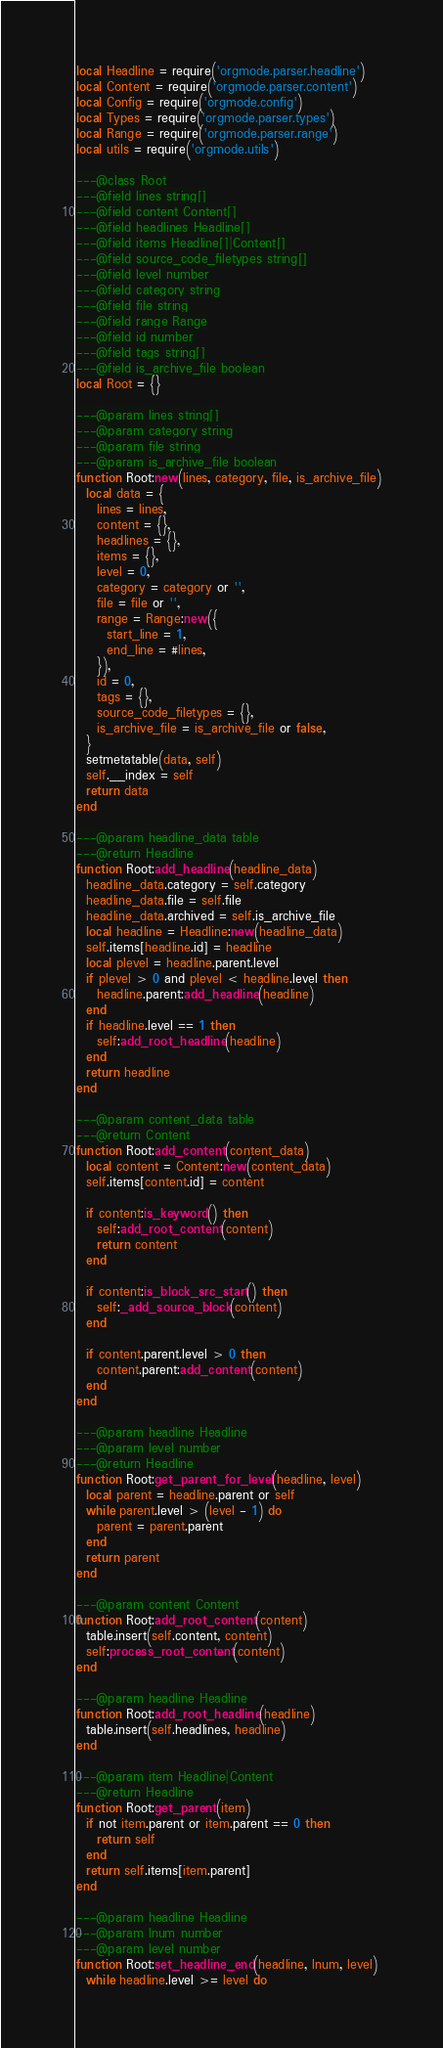Convert code to text. <code><loc_0><loc_0><loc_500><loc_500><_Lua_>local Headline = require('orgmode.parser.headline')
local Content = require('orgmode.parser.content')
local Config = require('orgmode.config')
local Types = require('orgmode.parser.types')
local Range = require('orgmode.parser.range')
local utils = require('orgmode.utils')

---@class Root
---@field lines string[]
---@field content Content[]
---@field headlines Headline[]
---@field items Headline[]|Content[]
---@field source_code_filetypes string[]
---@field level number
---@field category string
---@field file string
---@field range Range
---@field id number
---@field tags string[]
---@field is_archive_file boolean
local Root = {}

---@param lines string[]
---@param category string
---@param file string
---@param is_archive_file boolean
function Root:new(lines, category, file, is_archive_file)
  local data = {
    lines = lines,
    content = {},
    headlines = {},
    items = {},
    level = 0,
    category = category or '',
    file = file or '',
    range = Range:new({
      start_line = 1,
      end_line = #lines,
    }),
    id = 0,
    tags = {},
    source_code_filetypes = {},
    is_archive_file = is_archive_file or false,
  }
  setmetatable(data, self)
  self.__index = self
  return data
end

---@param headline_data table
---@return Headline
function Root:add_headline(headline_data)
  headline_data.category = self.category
  headline_data.file = self.file
  headline_data.archived = self.is_archive_file
  local headline = Headline:new(headline_data)
  self.items[headline.id] = headline
  local plevel = headline.parent.level
  if plevel > 0 and plevel < headline.level then
    headline.parent:add_headline(headline)
  end
  if headline.level == 1 then
    self:add_root_headline(headline)
  end
  return headline
end

---@param content_data table
---@return Content
function Root:add_content(content_data)
  local content = Content:new(content_data)
  self.items[content.id] = content

  if content:is_keyword() then
    self:add_root_content(content)
    return content
  end

  if content:is_block_src_start() then
    self:_add_source_block(content)
  end

  if content.parent.level > 0 then
    content.parent:add_content(content)
  end
end

---@param headline Headline
---@param level number
---@return Headline
function Root:get_parent_for_level(headline, level)
  local parent = headline.parent or self
  while parent.level > (level - 1) do
    parent = parent.parent
  end
  return parent
end

---@param content Content
function Root:add_root_content(content)
  table.insert(self.content, content)
  self:process_root_content(content)
end

---@param headline Headline
function Root:add_root_headline(headline)
  table.insert(self.headlines, headline)
end

---@param item Headline|Content
---@return Headline
function Root:get_parent(item)
  if not item.parent or item.parent == 0 then
    return self
  end
  return self.items[item.parent]
end

---@param headline Headline
---@param lnum number
---@param level number
function Root:set_headline_end(headline, lnum, level)
  while headline.level >= level do</code> 